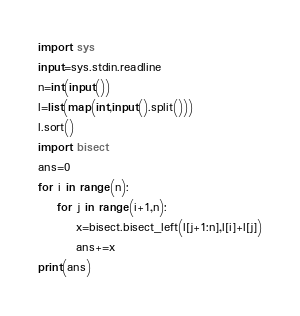<code> <loc_0><loc_0><loc_500><loc_500><_Python_>import sys
input=sys.stdin.readline
n=int(input())
l=list(map(int,input().split()))
l.sort()
import bisect
ans=0
for i in range(n):
    for j in range(i+1,n):
        x=bisect.bisect_left(l[j+1:n],l[i]+l[j])
        ans+=x
print(ans)
</code> 